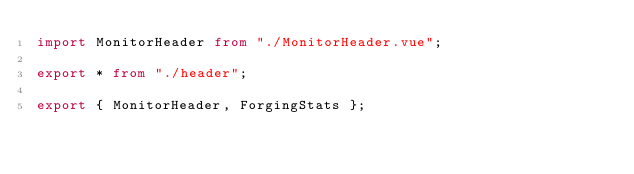Convert code to text. <code><loc_0><loc_0><loc_500><loc_500><_TypeScript_>import MonitorHeader from "./MonitorHeader.vue";

export * from "./header";

export { MonitorHeader, ForgingStats };
</code> 